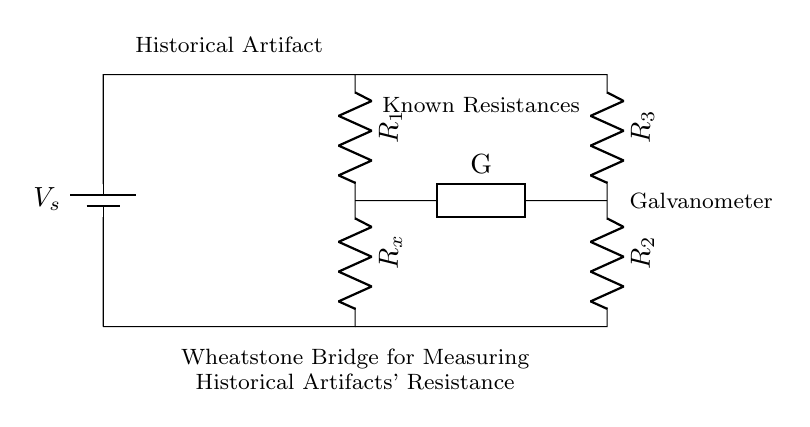What is the purpose of this circuit? The purpose of this circuit is to measure the electrical resistance of a historical artifact using a Wheatstone bridge configuration, allowing for precise comparisons against known resistances.
Answer: Measure resistance What is the component labeled as R_x? R_x represents the unknown resistance of the historical artifact being tested in the circuit.
Answer: Unknown resistance How many resistors are present in the circuit? There are four resistors present in the circuit: R_1, R_2, R_3, and R_x. This includes the known resistances and the unknown resistance to be measured.
Answer: Four What is the role of the galvanometer in the circuit? The galvanometer measures the current flow through the circuit; it is used to determine the balance of the Wheatstone bridge, indicating when the ratios of resistances are equal.
Answer: Measure current What occurs when the bridge is balanced? When the bridge is balanced, the current through the galvanometer is zero, indicating that the ratio of the known resistances equals the ratio of the unknown resistance to one of the known resistances. This allows for the calculation of the unknown resistance.
Answer: Zero current What is the voltage supply labeled as V_s? V_s is the supply voltage provided to the circuit, which powers the Wheatstone bridge arrangement and is essential for the measurement process.
Answer: Supply voltage What is indicated by the label "Historical Artifact"? The label "Historical Artifact" indicates the specific object whose electrical resistance is being measured in this circuit, highlighting the context of the experiment.
Answer: Historical artifact 